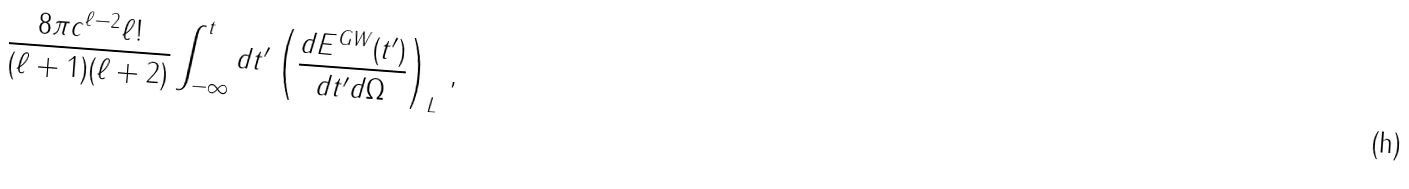<formula> <loc_0><loc_0><loc_500><loc_500>\frac { 8 \pi c ^ { \ell - 2 } \ell ! } { ( \ell + 1 ) ( \ell + 2 ) } \int _ { - \infty } ^ { t } d t ^ { \prime } \left ( \frac { d E ^ { G W } ( t ^ { \prime } ) } { d t ^ { \prime } d \Omega } \right ) _ { L } \, ,</formula> 